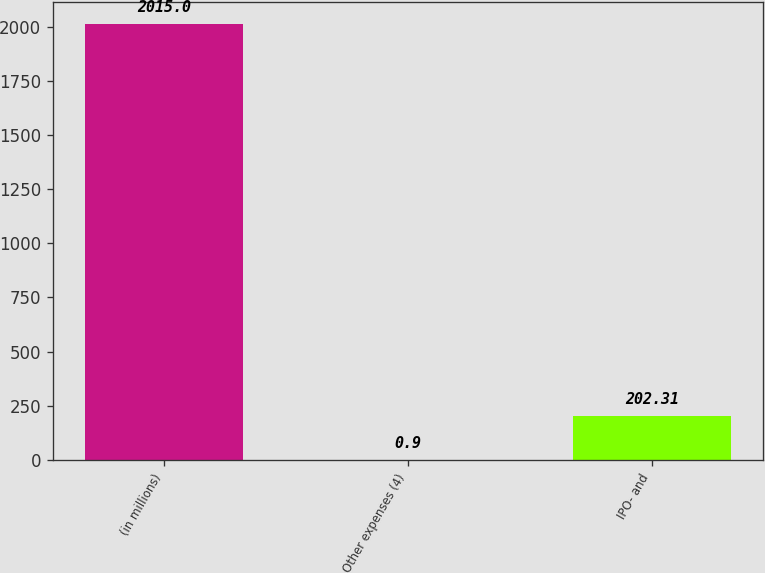Convert chart to OTSL. <chart><loc_0><loc_0><loc_500><loc_500><bar_chart><fcel>(in millions)<fcel>Other expenses (4)<fcel>IPO- and<nl><fcel>2015<fcel>0.9<fcel>202.31<nl></chart> 